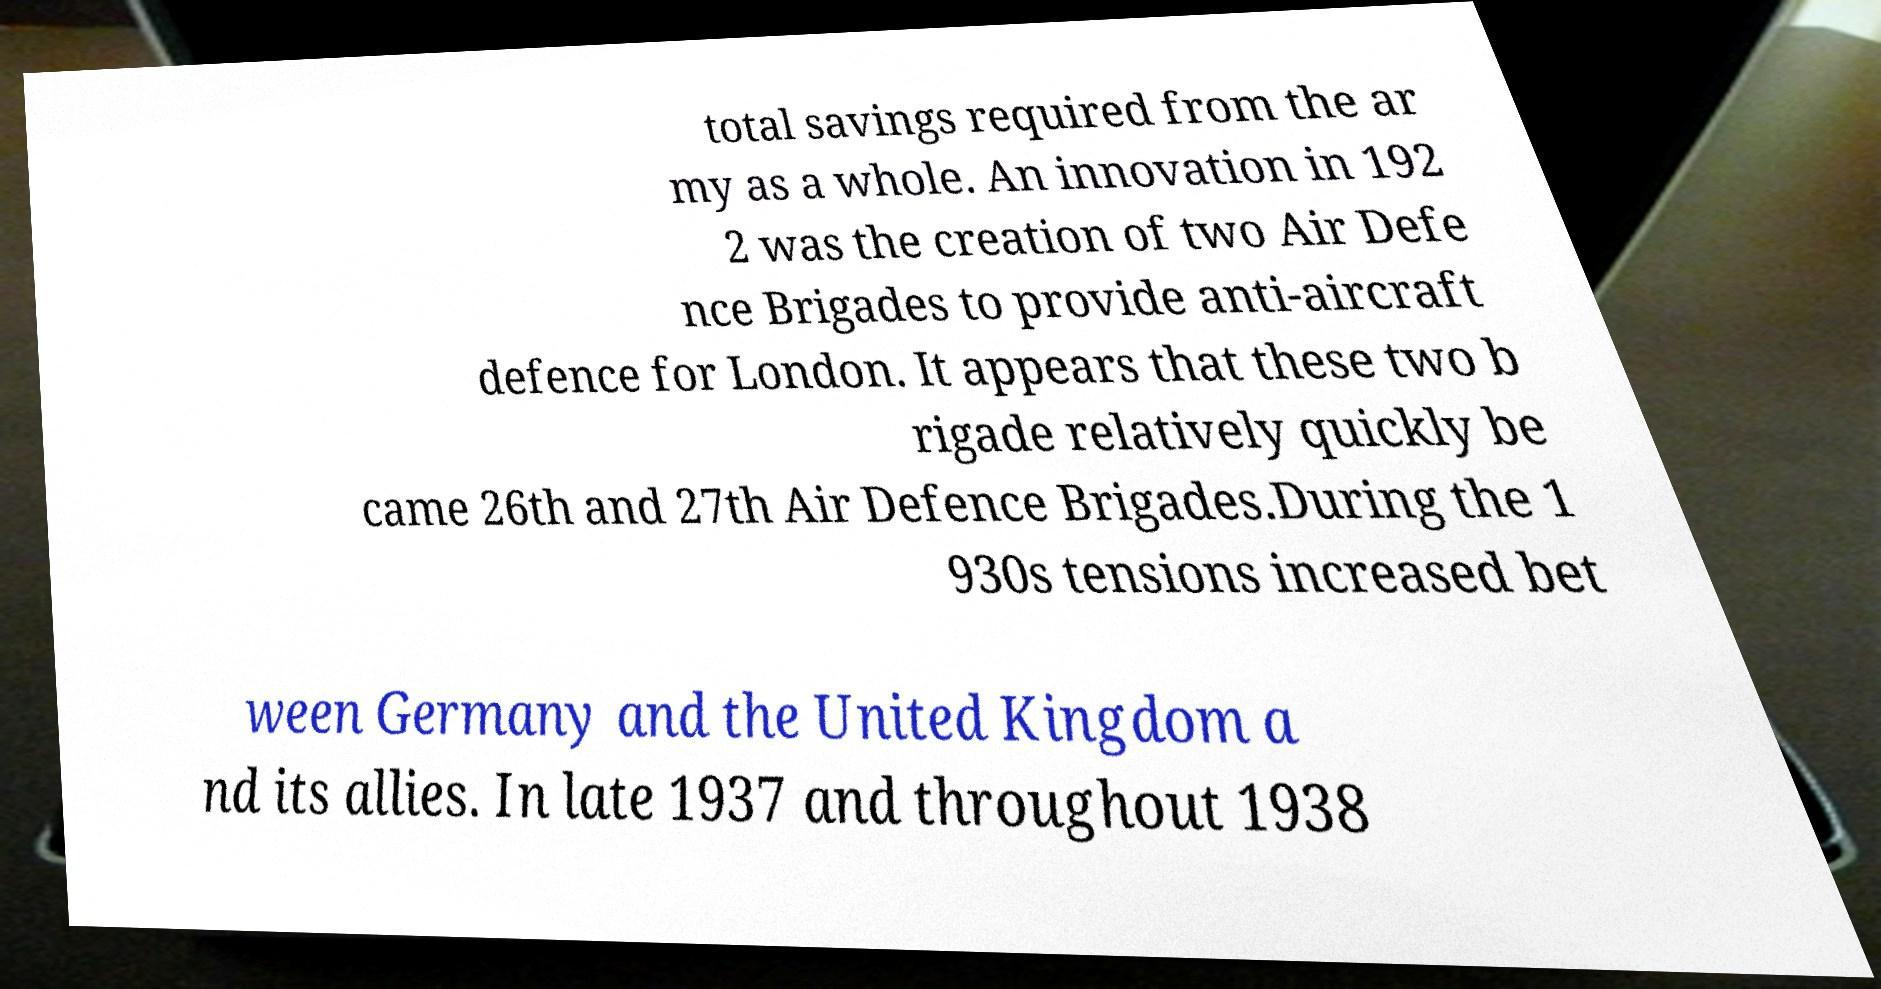What messages or text are displayed in this image? I need them in a readable, typed format. total savings required from the ar my as a whole. An innovation in 192 2 was the creation of two Air Defe nce Brigades to provide anti-aircraft defence for London. It appears that these two b rigade relatively quickly be came 26th and 27th Air Defence Brigades.During the 1 930s tensions increased bet ween Germany and the United Kingdom a nd its allies. In late 1937 and throughout 1938 